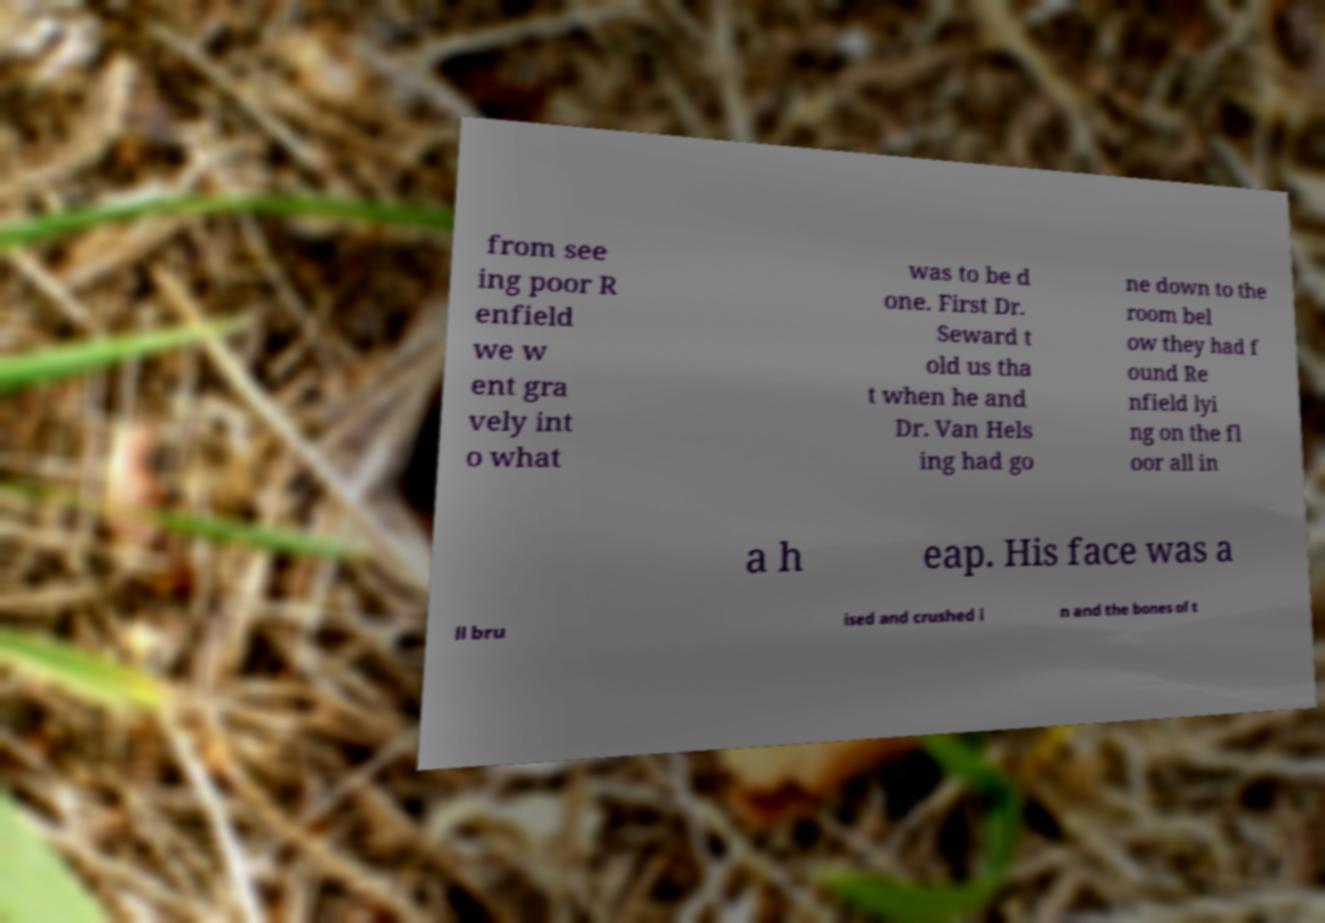Please identify and transcribe the text found in this image. from see ing poor R enfield we w ent gra vely int o what was to be d one. First Dr. Seward t old us tha t when he and Dr. Van Hels ing had go ne down to the room bel ow they had f ound Re nfield lyi ng on the fl oor all in a h eap. His face was a ll bru ised and crushed i n and the bones of t 